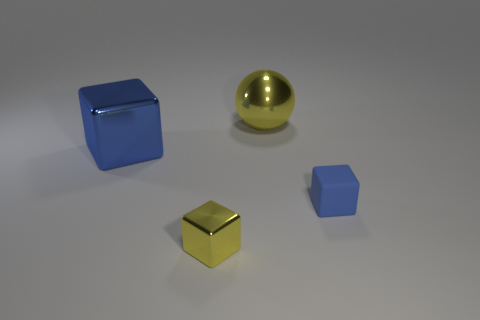Subtract all metallic cubes. How many cubes are left? 1 Add 2 blue rubber objects. How many objects exist? 6 Subtract all blue cubes. How many cubes are left? 1 Subtract all blocks. How many objects are left? 1 Subtract 1 spheres. How many spheres are left? 0 Subtract all blue balls. Subtract all yellow cubes. How many balls are left? 1 Subtract all brown cylinders. How many blue cubes are left? 2 Subtract all metallic objects. Subtract all small blue matte objects. How many objects are left? 0 Add 4 blue objects. How many blue objects are left? 6 Add 2 large yellow matte blocks. How many large yellow matte blocks exist? 2 